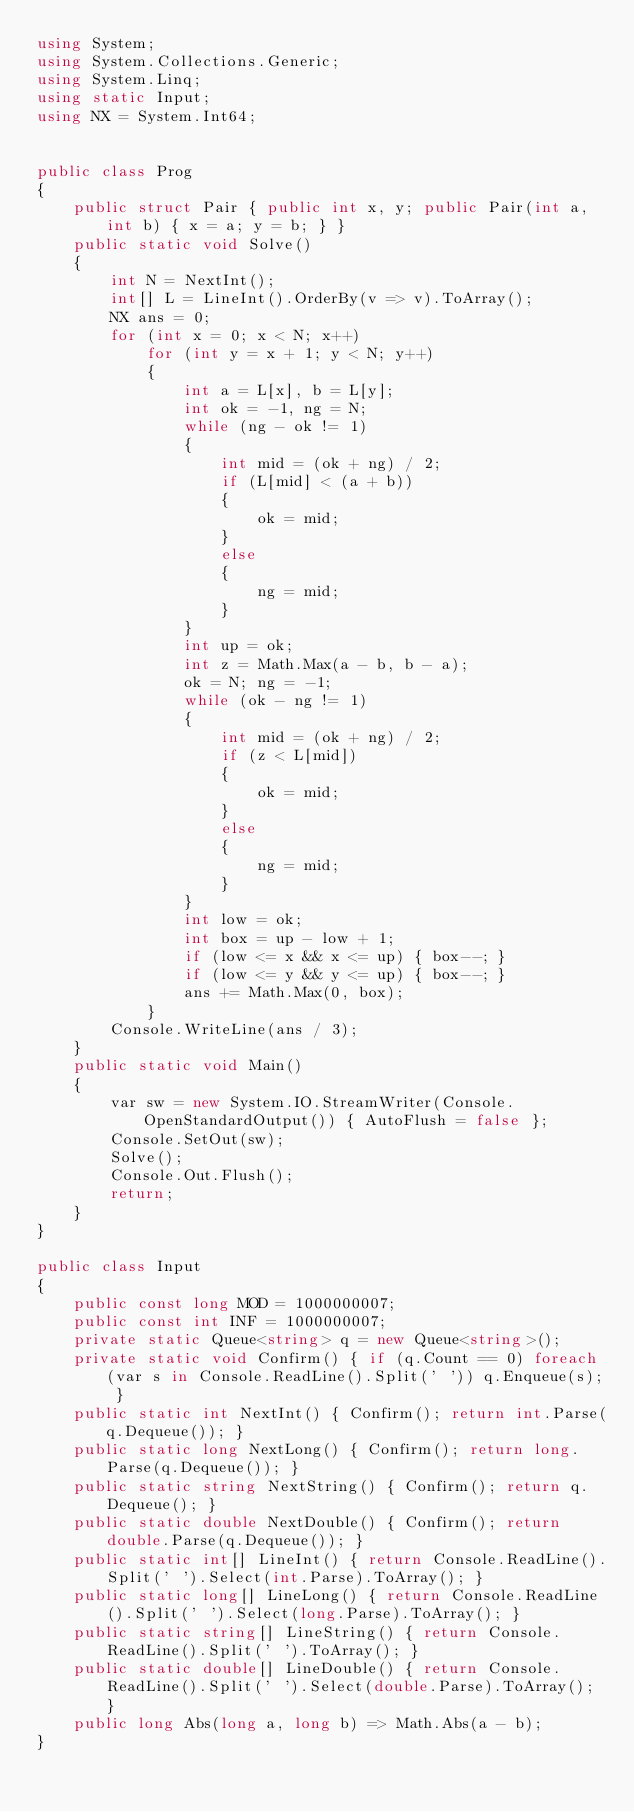<code> <loc_0><loc_0><loc_500><loc_500><_C#_>using System;
using System.Collections.Generic;
using System.Linq;
using static Input;
using NX = System.Int64;


public class Prog
{
    public struct Pair { public int x, y; public Pair(int a, int b) { x = a; y = b; } }
    public static void Solve()
    {
        int N = NextInt();
        int[] L = LineInt().OrderBy(v => v).ToArray();
        NX ans = 0;
        for (int x = 0; x < N; x++)
            for (int y = x + 1; y < N; y++)
            {
                int a = L[x], b = L[y];
                int ok = -1, ng = N;
                while (ng - ok != 1)
                {
                    int mid = (ok + ng) / 2;
                    if (L[mid] < (a + b))
                    {
                        ok = mid;
                    }
                    else
                    {
                        ng = mid;
                    }
                }
                int up = ok;
                int z = Math.Max(a - b, b - a);
                ok = N; ng = -1;
                while (ok - ng != 1)
                {
                    int mid = (ok + ng) / 2;
                    if (z < L[mid])
                    {
                        ok = mid;
                    }
                    else
                    {
                        ng = mid;
                    }
                }
                int low = ok;
                int box = up - low + 1;
                if (low <= x && x <= up) { box--; }
                if (low <= y && y <= up) { box--; }
                ans += Math.Max(0, box);
            }
        Console.WriteLine(ans / 3);
    }
    public static void Main()
    {
        var sw = new System.IO.StreamWriter(Console.OpenStandardOutput()) { AutoFlush = false };
        Console.SetOut(sw);
        Solve();
        Console.Out.Flush();
        return;
    }
}

public class Input
{
    public const long MOD = 1000000007;
    public const int INF = 1000000007;
    private static Queue<string> q = new Queue<string>();
    private static void Confirm() { if (q.Count == 0) foreach (var s in Console.ReadLine().Split(' ')) q.Enqueue(s); }
    public static int NextInt() { Confirm(); return int.Parse(q.Dequeue()); }
    public static long NextLong() { Confirm(); return long.Parse(q.Dequeue()); }
    public static string NextString() { Confirm(); return q.Dequeue(); }
    public static double NextDouble() { Confirm(); return double.Parse(q.Dequeue()); }
    public static int[] LineInt() { return Console.ReadLine().Split(' ').Select(int.Parse).ToArray(); }
    public static long[] LineLong() { return Console.ReadLine().Split(' ').Select(long.Parse).ToArray(); }
    public static string[] LineString() { return Console.ReadLine().Split(' ').ToArray(); }
    public static double[] LineDouble() { return Console.ReadLine().Split(' ').Select(double.Parse).ToArray(); }
    public long Abs(long a, long b) => Math.Abs(a - b);
}
</code> 